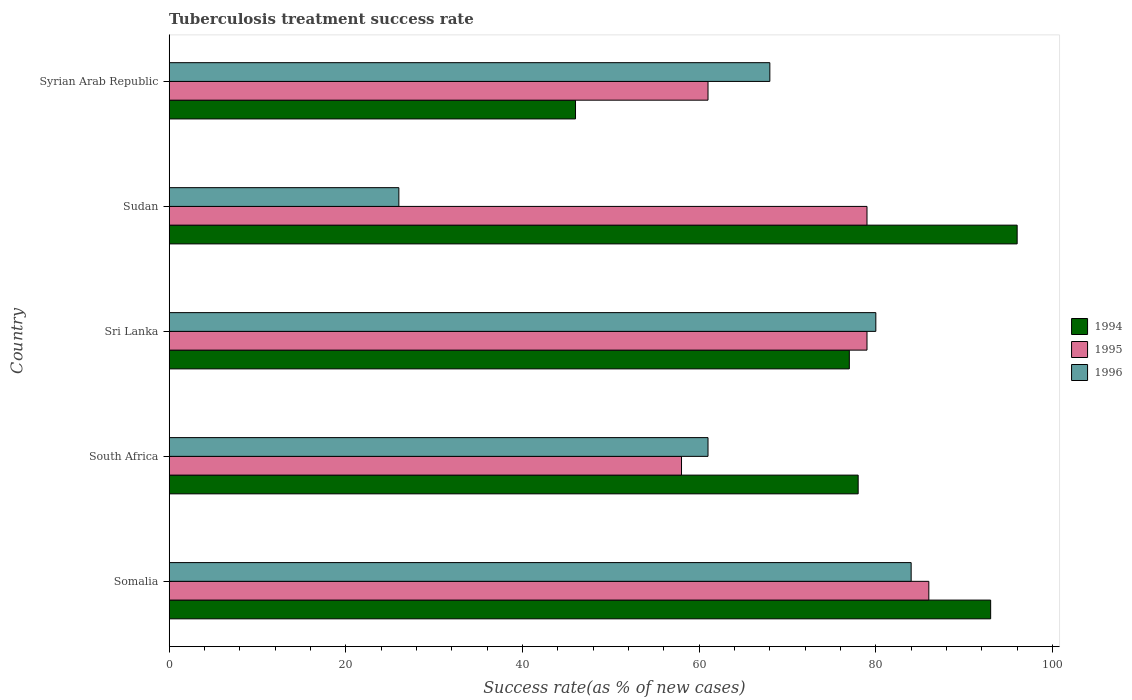How many different coloured bars are there?
Provide a succinct answer. 3. How many groups of bars are there?
Your answer should be compact. 5. Are the number of bars on each tick of the Y-axis equal?
Your answer should be compact. Yes. How many bars are there on the 4th tick from the bottom?
Your response must be concise. 3. What is the label of the 5th group of bars from the top?
Keep it short and to the point. Somalia. What is the tuberculosis treatment success rate in 1994 in Sudan?
Your response must be concise. 96. In which country was the tuberculosis treatment success rate in 1994 maximum?
Your answer should be compact. Sudan. In which country was the tuberculosis treatment success rate in 1994 minimum?
Your response must be concise. Syrian Arab Republic. What is the total tuberculosis treatment success rate in 1996 in the graph?
Give a very brief answer. 319. What is the difference between the tuberculosis treatment success rate in 1996 and tuberculosis treatment success rate in 1994 in Sudan?
Your answer should be very brief. -70. What is the ratio of the tuberculosis treatment success rate in 1996 in South Africa to that in Syrian Arab Republic?
Make the answer very short. 0.9. Is the tuberculosis treatment success rate in 1994 in Sri Lanka less than that in Sudan?
Provide a succinct answer. Yes. What is the difference between the highest and the second highest tuberculosis treatment success rate in 1996?
Make the answer very short. 4. What is the difference between the highest and the lowest tuberculosis treatment success rate in 1994?
Keep it short and to the point. 50. In how many countries, is the tuberculosis treatment success rate in 1995 greater than the average tuberculosis treatment success rate in 1995 taken over all countries?
Your answer should be compact. 3. Is the sum of the tuberculosis treatment success rate in 1995 in Somalia and Sri Lanka greater than the maximum tuberculosis treatment success rate in 1994 across all countries?
Your answer should be very brief. Yes. What is the difference between two consecutive major ticks on the X-axis?
Offer a very short reply. 20. Are the values on the major ticks of X-axis written in scientific E-notation?
Your answer should be very brief. No. Does the graph contain any zero values?
Your answer should be very brief. No. How many legend labels are there?
Provide a succinct answer. 3. What is the title of the graph?
Make the answer very short. Tuberculosis treatment success rate. Does "2000" appear as one of the legend labels in the graph?
Your response must be concise. No. What is the label or title of the X-axis?
Your response must be concise. Success rate(as % of new cases). What is the Success rate(as % of new cases) in 1994 in Somalia?
Keep it short and to the point. 93. What is the Success rate(as % of new cases) of 1996 in Somalia?
Your response must be concise. 84. What is the Success rate(as % of new cases) in 1996 in South Africa?
Provide a succinct answer. 61. What is the Success rate(as % of new cases) in 1995 in Sri Lanka?
Your answer should be compact. 79. What is the Success rate(as % of new cases) in 1994 in Sudan?
Ensure brevity in your answer.  96. What is the Success rate(as % of new cases) of 1995 in Sudan?
Offer a terse response. 79. What is the Success rate(as % of new cases) of 1994 in Syrian Arab Republic?
Your answer should be compact. 46. What is the Success rate(as % of new cases) in 1995 in Syrian Arab Republic?
Ensure brevity in your answer.  61. Across all countries, what is the maximum Success rate(as % of new cases) in 1994?
Provide a succinct answer. 96. Across all countries, what is the maximum Success rate(as % of new cases) in 1996?
Offer a very short reply. 84. Across all countries, what is the minimum Success rate(as % of new cases) of 1994?
Keep it short and to the point. 46. Across all countries, what is the minimum Success rate(as % of new cases) of 1995?
Ensure brevity in your answer.  58. Across all countries, what is the minimum Success rate(as % of new cases) of 1996?
Offer a terse response. 26. What is the total Success rate(as % of new cases) of 1994 in the graph?
Your answer should be compact. 390. What is the total Success rate(as % of new cases) in 1995 in the graph?
Offer a very short reply. 363. What is the total Success rate(as % of new cases) of 1996 in the graph?
Ensure brevity in your answer.  319. What is the difference between the Success rate(as % of new cases) in 1994 in Somalia and that in South Africa?
Offer a terse response. 15. What is the difference between the Success rate(as % of new cases) in 1994 in Somalia and that in Sudan?
Offer a very short reply. -3. What is the difference between the Success rate(as % of new cases) of 1995 in Somalia and that in Syrian Arab Republic?
Your response must be concise. 25. What is the difference between the Success rate(as % of new cases) of 1996 in Somalia and that in Syrian Arab Republic?
Ensure brevity in your answer.  16. What is the difference between the Success rate(as % of new cases) of 1994 in South Africa and that in Sri Lanka?
Your response must be concise. 1. What is the difference between the Success rate(as % of new cases) of 1995 in South Africa and that in Sri Lanka?
Give a very brief answer. -21. What is the difference between the Success rate(as % of new cases) of 1994 in South Africa and that in Sudan?
Provide a short and direct response. -18. What is the difference between the Success rate(as % of new cases) of 1996 in South Africa and that in Sudan?
Provide a short and direct response. 35. What is the difference between the Success rate(as % of new cases) of 1994 in South Africa and that in Syrian Arab Republic?
Your answer should be very brief. 32. What is the difference between the Success rate(as % of new cases) of 1995 in South Africa and that in Syrian Arab Republic?
Ensure brevity in your answer.  -3. What is the difference between the Success rate(as % of new cases) of 1995 in Sri Lanka and that in Syrian Arab Republic?
Your answer should be very brief. 18. What is the difference between the Success rate(as % of new cases) of 1995 in Sudan and that in Syrian Arab Republic?
Your response must be concise. 18. What is the difference between the Success rate(as % of new cases) of 1996 in Sudan and that in Syrian Arab Republic?
Provide a succinct answer. -42. What is the difference between the Success rate(as % of new cases) in 1994 in Somalia and the Success rate(as % of new cases) in 1996 in Sri Lanka?
Provide a short and direct response. 13. What is the difference between the Success rate(as % of new cases) in 1995 in Somalia and the Success rate(as % of new cases) in 1996 in Sri Lanka?
Provide a short and direct response. 6. What is the difference between the Success rate(as % of new cases) of 1994 in Somalia and the Success rate(as % of new cases) of 1995 in Sudan?
Keep it short and to the point. 14. What is the difference between the Success rate(as % of new cases) of 1994 in Somalia and the Success rate(as % of new cases) of 1996 in Sudan?
Make the answer very short. 67. What is the difference between the Success rate(as % of new cases) of 1995 in Somalia and the Success rate(as % of new cases) of 1996 in Sudan?
Offer a terse response. 60. What is the difference between the Success rate(as % of new cases) in 1994 in Somalia and the Success rate(as % of new cases) in 1996 in Syrian Arab Republic?
Your answer should be compact. 25. What is the difference between the Success rate(as % of new cases) in 1995 in Somalia and the Success rate(as % of new cases) in 1996 in Syrian Arab Republic?
Keep it short and to the point. 18. What is the difference between the Success rate(as % of new cases) in 1994 in South Africa and the Success rate(as % of new cases) in 1996 in Sri Lanka?
Your answer should be very brief. -2. What is the difference between the Success rate(as % of new cases) of 1995 in South Africa and the Success rate(as % of new cases) of 1996 in Sri Lanka?
Ensure brevity in your answer.  -22. What is the difference between the Success rate(as % of new cases) of 1995 in South Africa and the Success rate(as % of new cases) of 1996 in Sudan?
Ensure brevity in your answer.  32. What is the difference between the Success rate(as % of new cases) of 1994 in Sri Lanka and the Success rate(as % of new cases) of 1995 in Sudan?
Ensure brevity in your answer.  -2. What is the difference between the Success rate(as % of new cases) of 1995 in Sri Lanka and the Success rate(as % of new cases) of 1996 in Sudan?
Give a very brief answer. 53. What is the difference between the Success rate(as % of new cases) of 1995 in Sudan and the Success rate(as % of new cases) of 1996 in Syrian Arab Republic?
Your answer should be compact. 11. What is the average Success rate(as % of new cases) in 1994 per country?
Offer a terse response. 78. What is the average Success rate(as % of new cases) of 1995 per country?
Keep it short and to the point. 72.6. What is the average Success rate(as % of new cases) of 1996 per country?
Give a very brief answer. 63.8. What is the difference between the Success rate(as % of new cases) of 1994 and Success rate(as % of new cases) of 1995 in South Africa?
Keep it short and to the point. 20. What is the difference between the Success rate(as % of new cases) in 1995 and Success rate(as % of new cases) in 1996 in South Africa?
Keep it short and to the point. -3. What is the difference between the Success rate(as % of new cases) in 1994 and Success rate(as % of new cases) in 1995 in Sri Lanka?
Offer a terse response. -2. What is the difference between the Success rate(as % of new cases) in 1994 and Success rate(as % of new cases) in 1996 in Sri Lanka?
Ensure brevity in your answer.  -3. What is the difference between the Success rate(as % of new cases) of 1995 and Success rate(as % of new cases) of 1996 in Sri Lanka?
Give a very brief answer. -1. What is the difference between the Success rate(as % of new cases) of 1994 and Success rate(as % of new cases) of 1995 in Sudan?
Keep it short and to the point. 17. What is the difference between the Success rate(as % of new cases) in 1995 and Success rate(as % of new cases) in 1996 in Syrian Arab Republic?
Your response must be concise. -7. What is the ratio of the Success rate(as % of new cases) in 1994 in Somalia to that in South Africa?
Your answer should be very brief. 1.19. What is the ratio of the Success rate(as % of new cases) in 1995 in Somalia to that in South Africa?
Keep it short and to the point. 1.48. What is the ratio of the Success rate(as % of new cases) in 1996 in Somalia to that in South Africa?
Offer a terse response. 1.38. What is the ratio of the Success rate(as % of new cases) in 1994 in Somalia to that in Sri Lanka?
Make the answer very short. 1.21. What is the ratio of the Success rate(as % of new cases) of 1995 in Somalia to that in Sri Lanka?
Ensure brevity in your answer.  1.09. What is the ratio of the Success rate(as % of new cases) in 1994 in Somalia to that in Sudan?
Keep it short and to the point. 0.97. What is the ratio of the Success rate(as % of new cases) of 1995 in Somalia to that in Sudan?
Your answer should be compact. 1.09. What is the ratio of the Success rate(as % of new cases) in 1996 in Somalia to that in Sudan?
Offer a terse response. 3.23. What is the ratio of the Success rate(as % of new cases) in 1994 in Somalia to that in Syrian Arab Republic?
Provide a succinct answer. 2.02. What is the ratio of the Success rate(as % of new cases) of 1995 in Somalia to that in Syrian Arab Republic?
Provide a short and direct response. 1.41. What is the ratio of the Success rate(as % of new cases) in 1996 in Somalia to that in Syrian Arab Republic?
Give a very brief answer. 1.24. What is the ratio of the Success rate(as % of new cases) of 1995 in South Africa to that in Sri Lanka?
Offer a terse response. 0.73. What is the ratio of the Success rate(as % of new cases) of 1996 in South Africa to that in Sri Lanka?
Offer a very short reply. 0.76. What is the ratio of the Success rate(as % of new cases) in 1994 in South Africa to that in Sudan?
Offer a very short reply. 0.81. What is the ratio of the Success rate(as % of new cases) in 1995 in South Africa to that in Sudan?
Make the answer very short. 0.73. What is the ratio of the Success rate(as % of new cases) in 1996 in South Africa to that in Sudan?
Your response must be concise. 2.35. What is the ratio of the Success rate(as % of new cases) in 1994 in South Africa to that in Syrian Arab Republic?
Make the answer very short. 1.7. What is the ratio of the Success rate(as % of new cases) of 1995 in South Africa to that in Syrian Arab Republic?
Provide a succinct answer. 0.95. What is the ratio of the Success rate(as % of new cases) in 1996 in South Africa to that in Syrian Arab Republic?
Your answer should be very brief. 0.9. What is the ratio of the Success rate(as % of new cases) of 1994 in Sri Lanka to that in Sudan?
Provide a short and direct response. 0.8. What is the ratio of the Success rate(as % of new cases) of 1996 in Sri Lanka to that in Sudan?
Provide a short and direct response. 3.08. What is the ratio of the Success rate(as % of new cases) of 1994 in Sri Lanka to that in Syrian Arab Republic?
Your answer should be compact. 1.67. What is the ratio of the Success rate(as % of new cases) in 1995 in Sri Lanka to that in Syrian Arab Republic?
Your response must be concise. 1.3. What is the ratio of the Success rate(as % of new cases) of 1996 in Sri Lanka to that in Syrian Arab Republic?
Provide a succinct answer. 1.18. What is the ratio of the Success rate(as % of new cases) in 1994 in Sudan to that in Syrian Arab Republic?
Keep it short and to the point. 2.09. What is the ratio of the Success rate(as % of new cases) of 1995 in Sudan to that in Syrian Arab Republic?
Ensure brevity in your answer.  1.3. What is the ratio of the Success rate(as % of new cases) of 1996 in Sudan to that in Syrian Arab Republic?
Make the answer very short. 0.38. What is the difference between the highest and the second highest Success rate(as % of new cases) in 1994?
Give a very brief answer. 3. What is the difference between the highest and the second highest Success rate(as % of new cases) in 1995?
Provide a succinct answer. 7. What is the difference between the highest and the lowest Success rate(as % of new cases) of 1995?
Ensure brevity in your answer.  28. What is the difference between the highest and the lowest Success rate(as % of new cases) in 1996?
Ensure brevity in your answer.  58. 